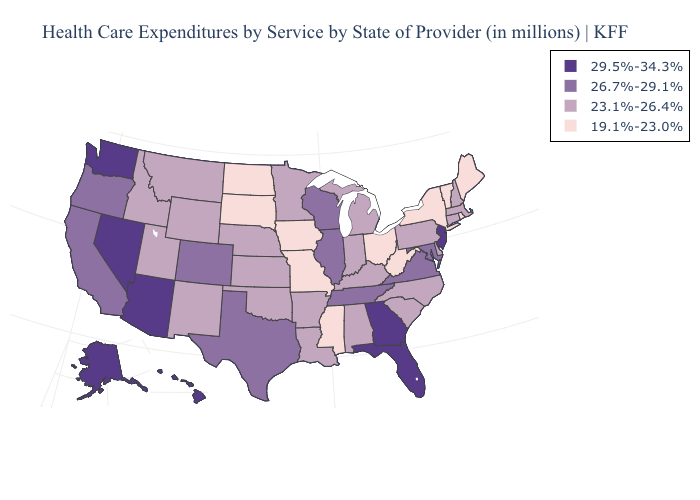What is the highest value in states that border California?
Write a very short answer. 29.5%-34.3%. How many symbols are there in the legend?
Keep it brief. 4. Among the states that border Louisiana , does Arkansas have the lowest value?
Write a very short answer. No. Among the states that border Georgia , which have the highest value?
Short answer required. Florida. Does Georgia have the highest value in the South?
Write a very short answer. Yes. Which states have the lowest value in the MidWest?
Concise answer only. Iowa, Missouri, North Dakota, Ohio, South Dakota. What is the value of North Carolina?
Give a very brief answer. 23.1%-26.4%. Does Nevada have the lowest value in the USA?
Keep it brief. No. Among the states that border Kentucky , does Ohio have the lowest value?
Be succinct. Yes. What is the lowest value in the South?
Answer briefly. 19.1%-23.0%. Name the states that have a value in the range 29.5%-34.3%?
Quick response, please. Alaska, Arizona, Florida, Georgia, Hawaii, Nevada, New Jersey, Washington. What is the highest value in the South ?
Keep it brief. 29.5%-34.3%. Name the states that have a value in the range 29.5%-34.3%?
Write a very short answer. Alaska, Arizona, Florida, Georgia, Hawaii, Nevada, New Jersey, Washington. Among the states that border Montana , which have the lowest value?
Quick response, please. North Dakota, South Dakota. Does the first symbol in the legend represent the smallest category?
Give a very brief answer. No. 